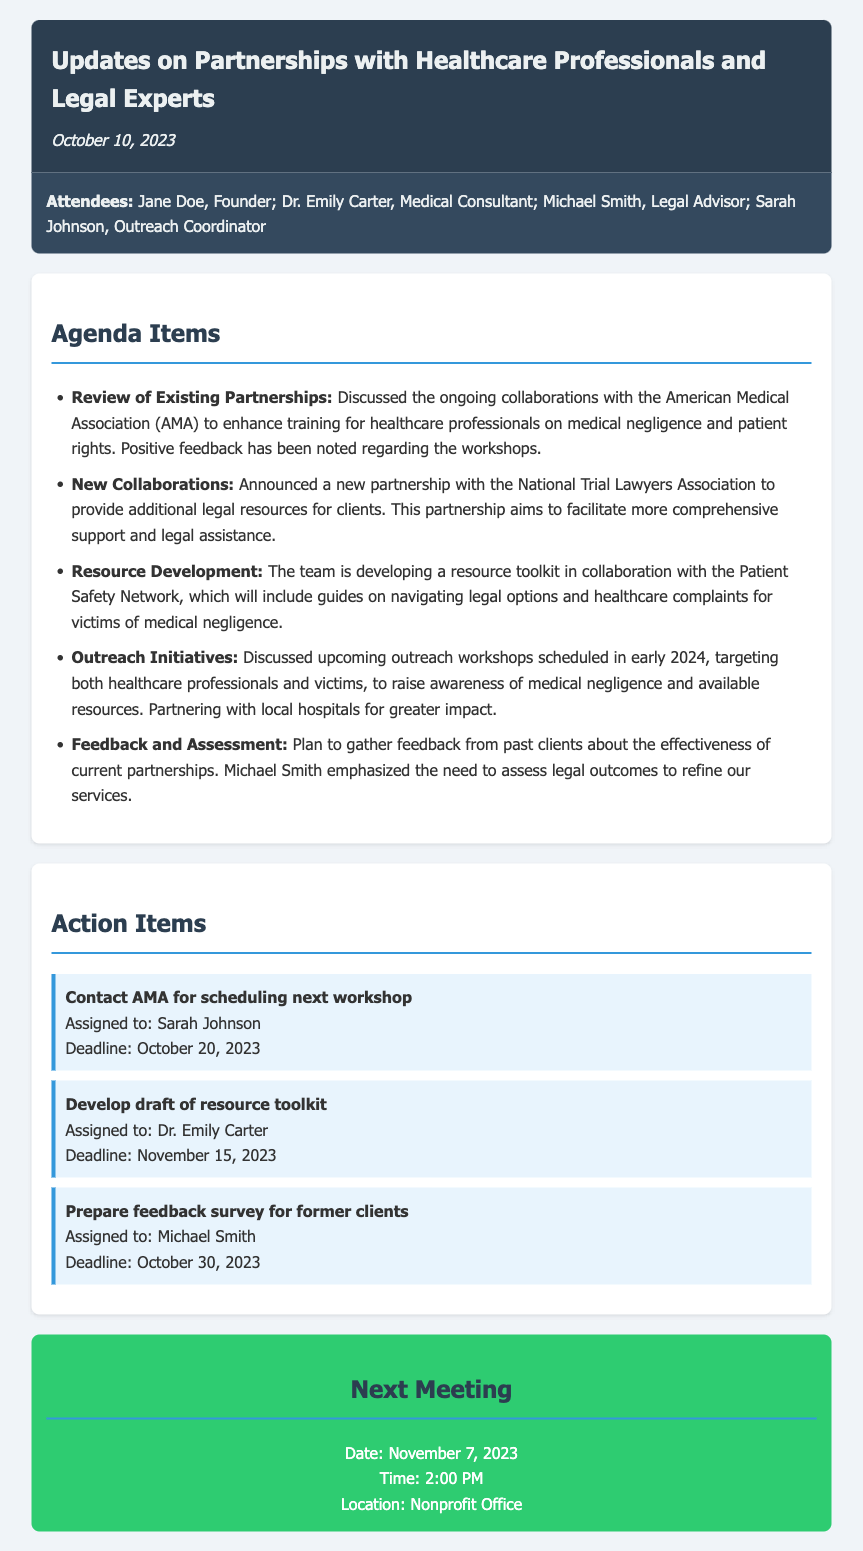What is the date of the meeting? The date of the meeting is stated at the top of the document under the header section.
Answer: October 10, 2023 Who is the Medical Consultant mentioned in the attendees? The attendees section lists the roles and names of individuals present at the meeting, including the Medical Consultant.
Answer: Dr. Emily Carter What new partnership was announced during the meeting? The agenda item specifically discusses a new collaboration that was announced in the meeting.
Answer: National Trial Lawyers Association What is the deadline for developing the draft of the resource toolkit? The action items section includes specific deadlines assigned to various tasks mentioned during the meeting.
Answer: November 15, 2023 How many attendees are listed in the document? The attendees section explicitly provides a list of individuals who participated, which can be counted.
Answer: Four What initiative is planned for early 2024? The agenda items mention specific outreach initiatives targeting healthcare professionals and victims.
Answer: Outreach workshops What is the assigned task for Sarah Johnson? The action items section details specific tasks assigned to attendees, including who they were assigned to.
Answer: Contact AMA for scheduling next workshop What is the primary reason for gathering feedback from past clients? The agenda item discusses the purpose behind gathering feedback, emphasizing the assessment of legal outcomes.
Answer: To refine our services 